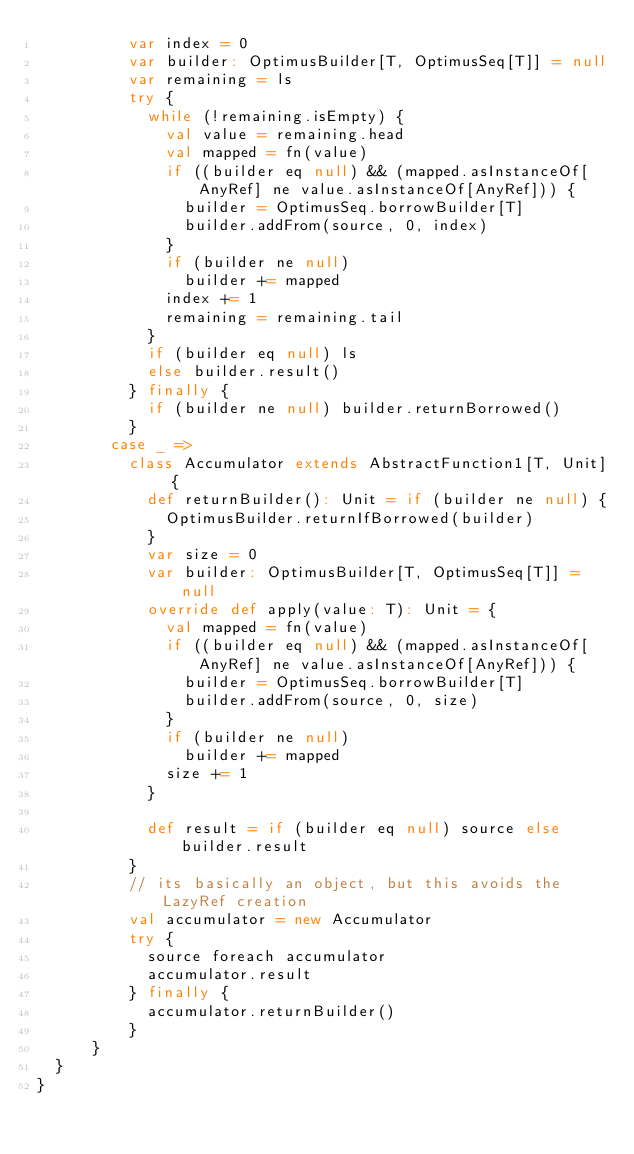Convert code to text. <code><loc_0><loc_0><loc_500><loc_500><_Scala_>          var index = 0
          var builder: OptimusBuilder[T, OptimusSeq[T]] = null
          var remaining = ls
          try {
            while (!remaining.isEmpty) {
              val value = remaining.head
              val mapped = fn(value)
              if ((builder eq null) && (mapped.asInstanceOf[AnyRef] ne value.asInstanceOf[AnyRef])) {
                builder = OptimusSeq.borrowBuilder[T]
                builder.addFrom(source, 0, index)
              }
              if (builder ne null)
                builder += mapped
              index += 1
              remaining = remaining.tail
            }
            if (builder eq null) ls
            else builder.result()
          } finally {
            if (builder ne null) builder.returnBorrowed()
          }
        case _ =>
          class Accumulator extends AbstractFunction1[T, Unit] {
            def returnBuilder(): Unit = if (builder ne null) {
              OptimusBuilder.returnIfBorrowed(builder)
            }
            var size = 0
            var builder: OptimusBuilder[T, OptimusSeq[T]] = null
            override def apply(value: T): Unit = {
              val mapped = fn(value)
              if ((builder eq null) && (mapped.asInstanceOf[AnyRef] ne value.asInstanceOf[AnyRef])) {
                builder = OptimusSeq.borrowBuilder[T]
                builder.addFrom(source, 0, size)
              }
              if (builder ne null)
                builder += mapped
              size += 1
            }

            def result = if (builder eq null) source else builder.result
          }
          // its basically an object, but this avoids the LazyRef creation
          val accumulator = new Accumulator
          try {
            source foreach accumulator
            accumulator.result
          } finally {
            accumulator.returnBuilder()
          }
      }
  }
}
</code> 